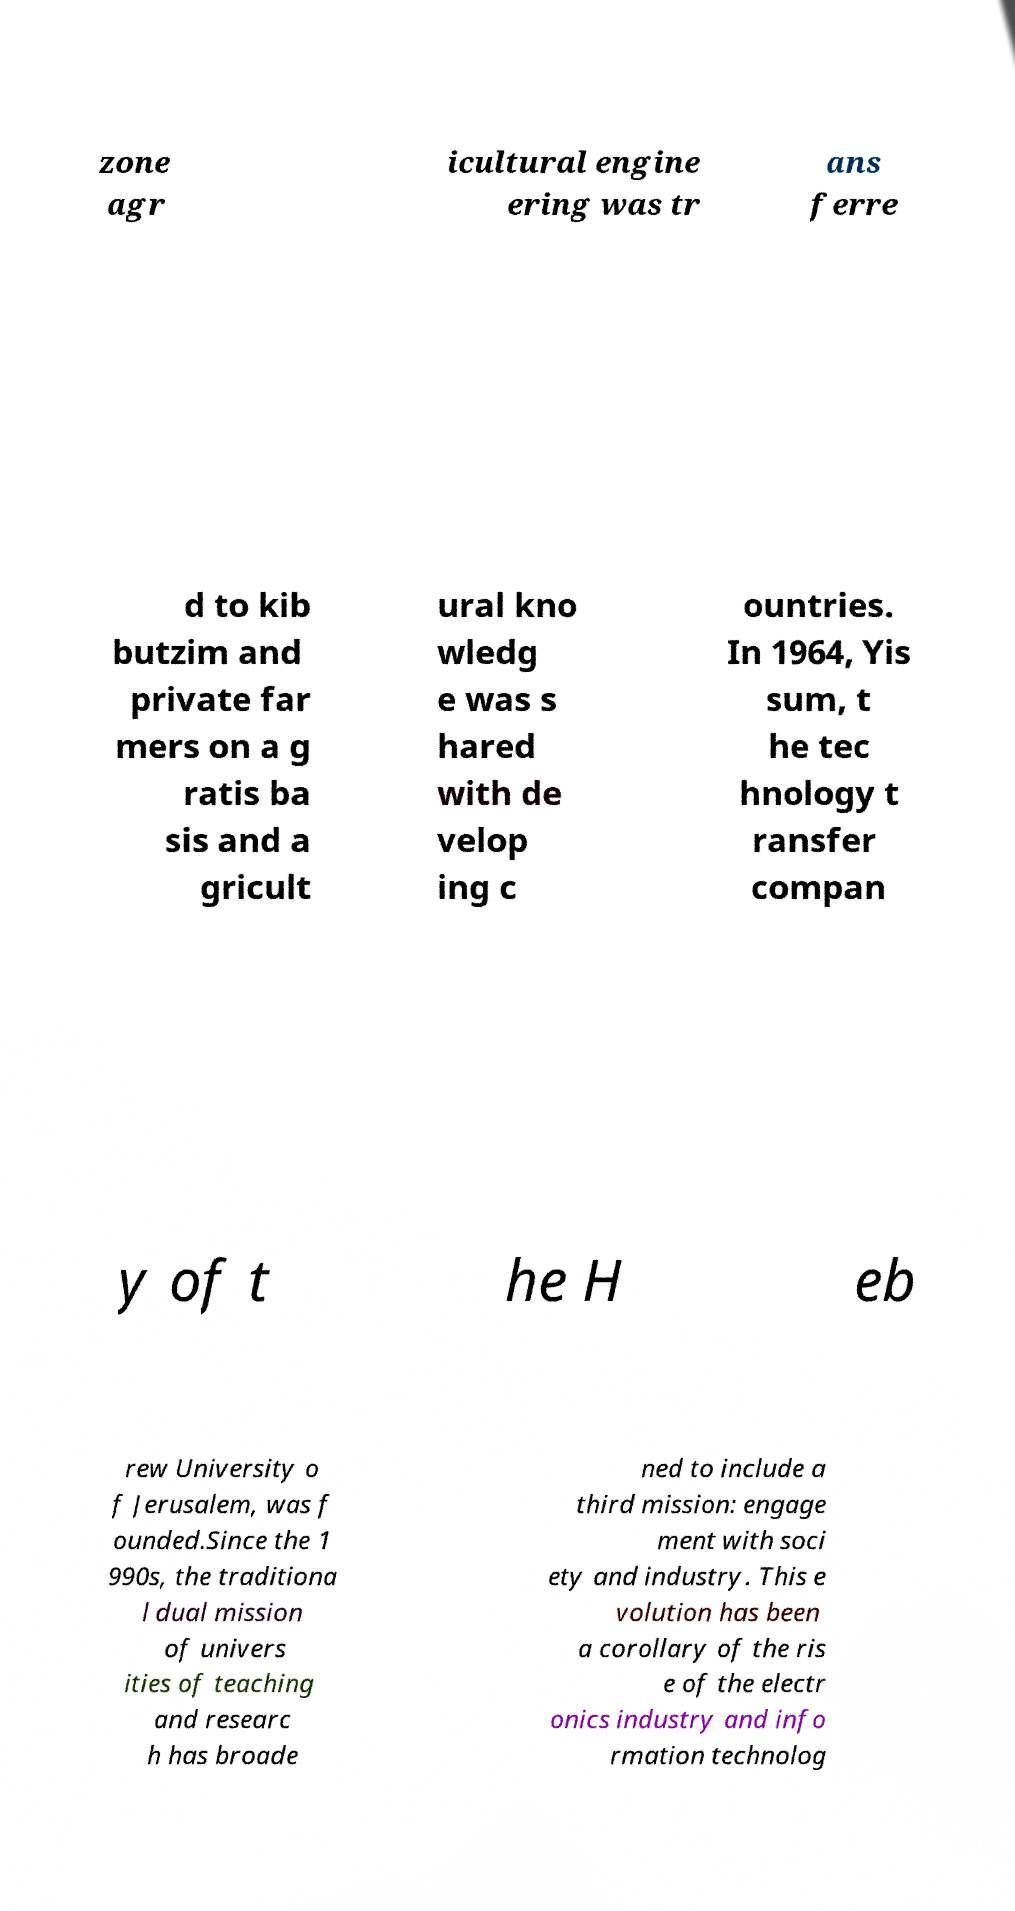Please read and relay the text visible in this image. What does it say? zone agr icultural engine ering was tr ans ferre d to kib butzim and private far mers on a g ratis ba sis and a gricult ural kno wledg e was s hared with de velop ing c ountries. In 1964, Yis sum, t he tec hnology t ransfer compan y of t he H eb rew University o f Jerusalem, was f ounded.Since the 1 990s, the traditiona l dual mission of univers ities of teaching and researc h has broade ned to include a third mission: engage ment with soci ety and industry. This e volution has been a corollary of the ris e of the electr onics industry and info rmation technolog 